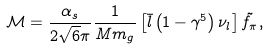Convert formula to latex. <formula><loc_0><loc_0><loc_500><loc_500>\mathcal { M } = \frac { \alpha _ { s } } { 2 \sqrt { 6 } \pi } \frac { 1 } { M m _ { g } } \left [ \bar { l } \left ( 1 - \gamma ^ { 5 } \right ) \nu _ { l } \right ] \tilde { f _ { \pi } } ,</formula> 